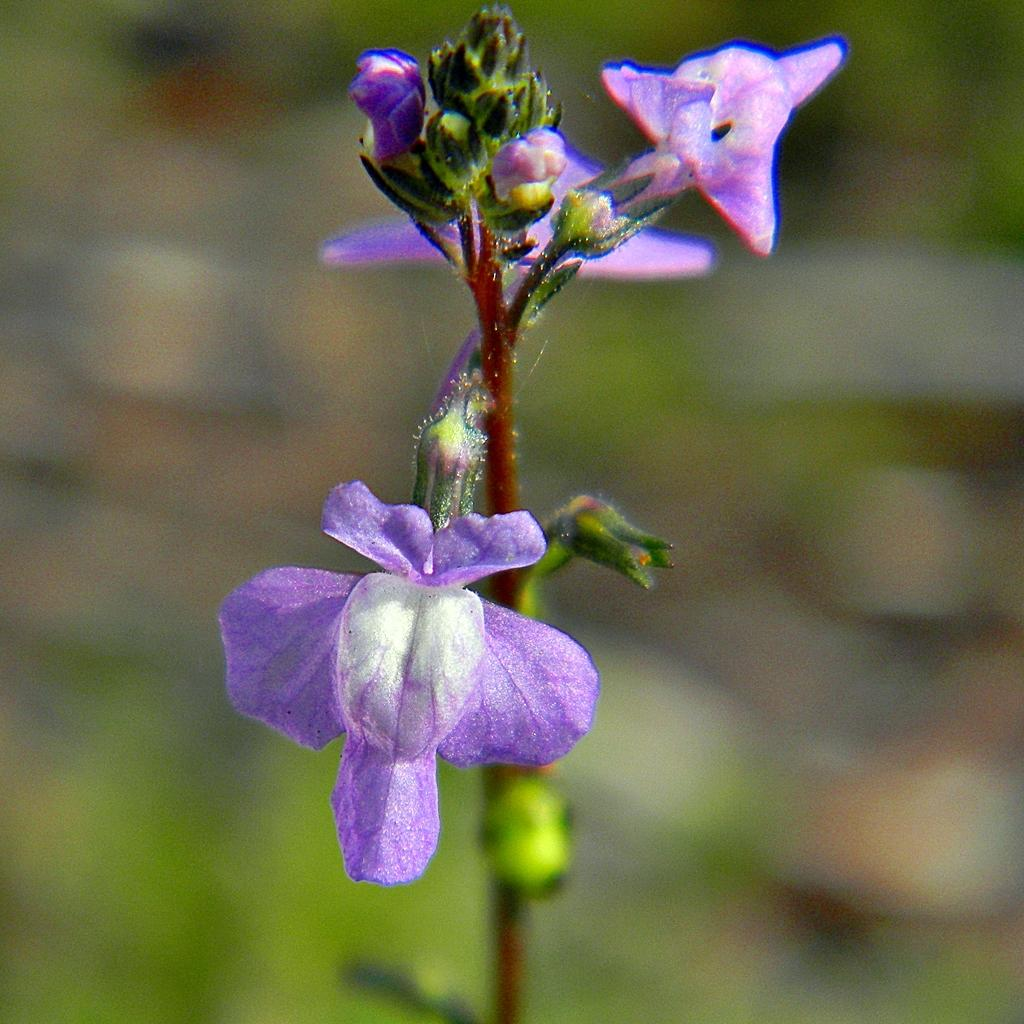What type of plant life is present in the image? There are flowers, buds, and stems in the image. Can you describe the different parts of the plants in the image? The flowers are the colorful parts of the plants, the buds are the unopened flowers, and the stems are the long, thin parts that connect the flowers and buds to the ground. What is the background of the image like? The background of the image is blurry. Where is the straw located in the image? There is no straw present in the image. 